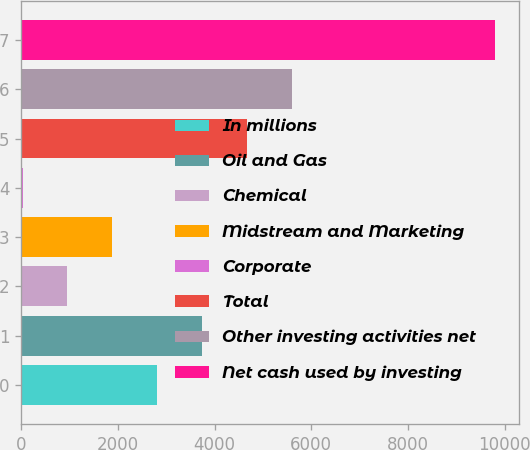Convert chart to OTSL. <chart><loc_0><loc_0><loc_500><loc_500><bar_chart><fcel>In millions<fcel>Oil and Gas<fcel>Chemical<fcel>Midstream and Marketing<fcel>Corporate<fcel>Total<fcel>Other investing activities net<fcel>Net cash used by investing<nl><fcel>2813.7<fcel>3739.6<fcel>961.9<fcel>1887.8<fcel>36<fcel>4665.5<fcel>5591.4<fcel>9805.9<nl></chart> 